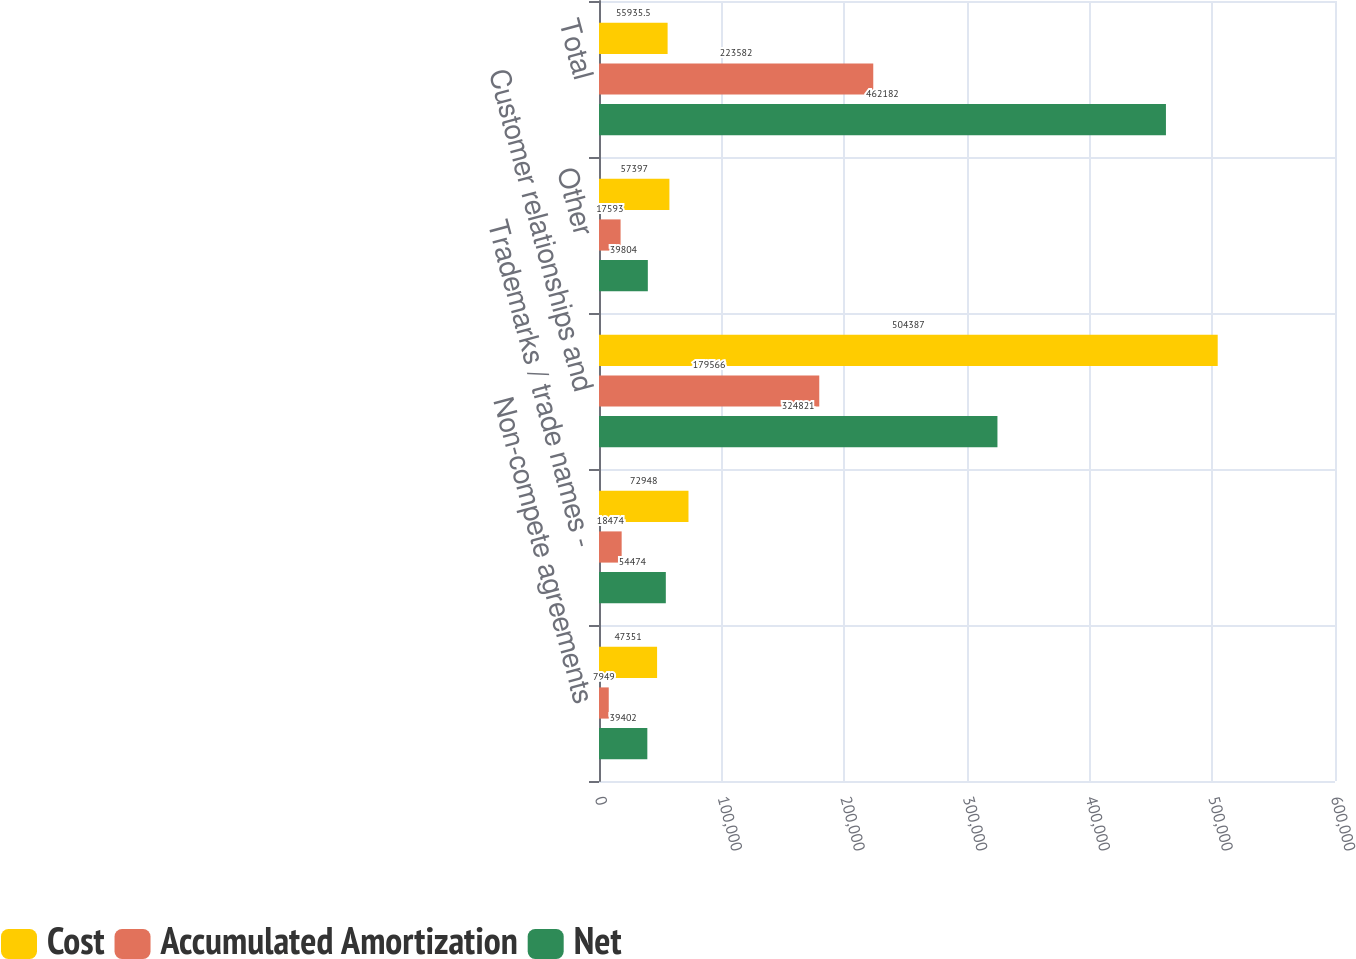<chart> <loc_0><loc_0><loc_500><loc_500><stacked_bar_chart><ecel><fcel>Non-compete agreements<fcel>Trademarks / trade names -<fcel>Customer relationships and<fcel>Other<fcel>Total<nl><fcel>Cost<fcel>47351<fcel>72948<fcel>504387<fcel>57397<fcel>55935.5<nl><fcel>Accumulated Amortization<fcel>7949<fcel>18474<fcel>179566<fcel>17593<fcel>223582<nl><fcel>Net<fcel>39402<fcel>54474<fcel>324821<fcel>39804<fcel>462182<nl></chart> 